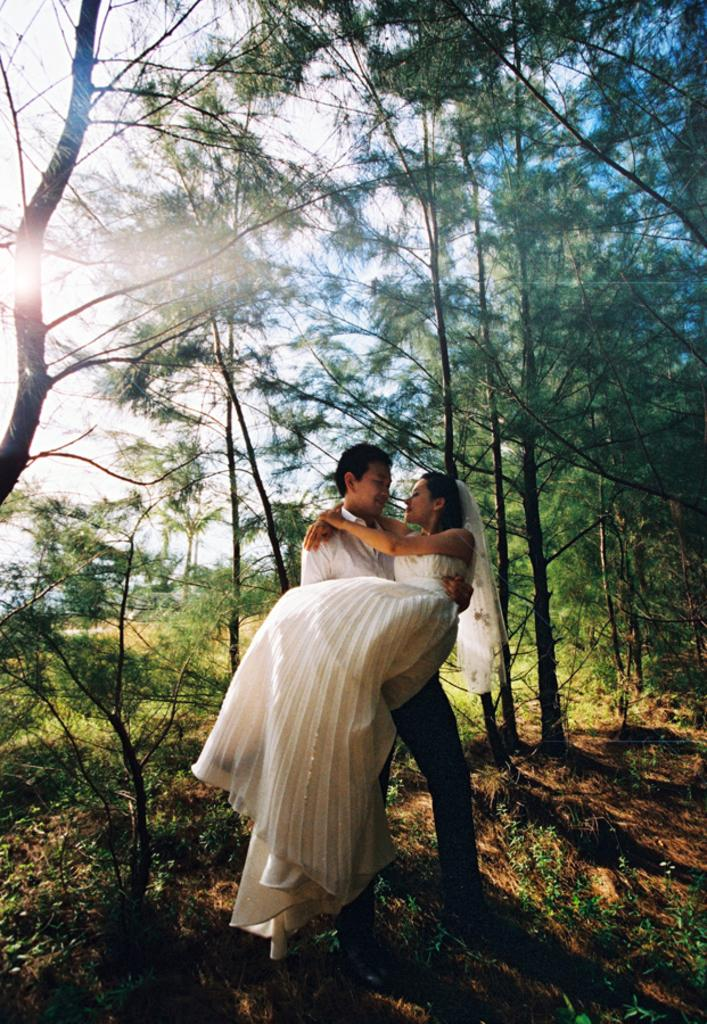What is happening in the image involving a person? The person in the image is lifting a lady. Can you describe the lady's attire in the image? The lady is wearing a white gown. What can be seen in the background of the image? There are trees and plants in the background of the image. What type of advertisement can be seen on the lady's gown in the image? There is no advertisement present on the lady's gown in the image; she is simply wearing a white gown. 